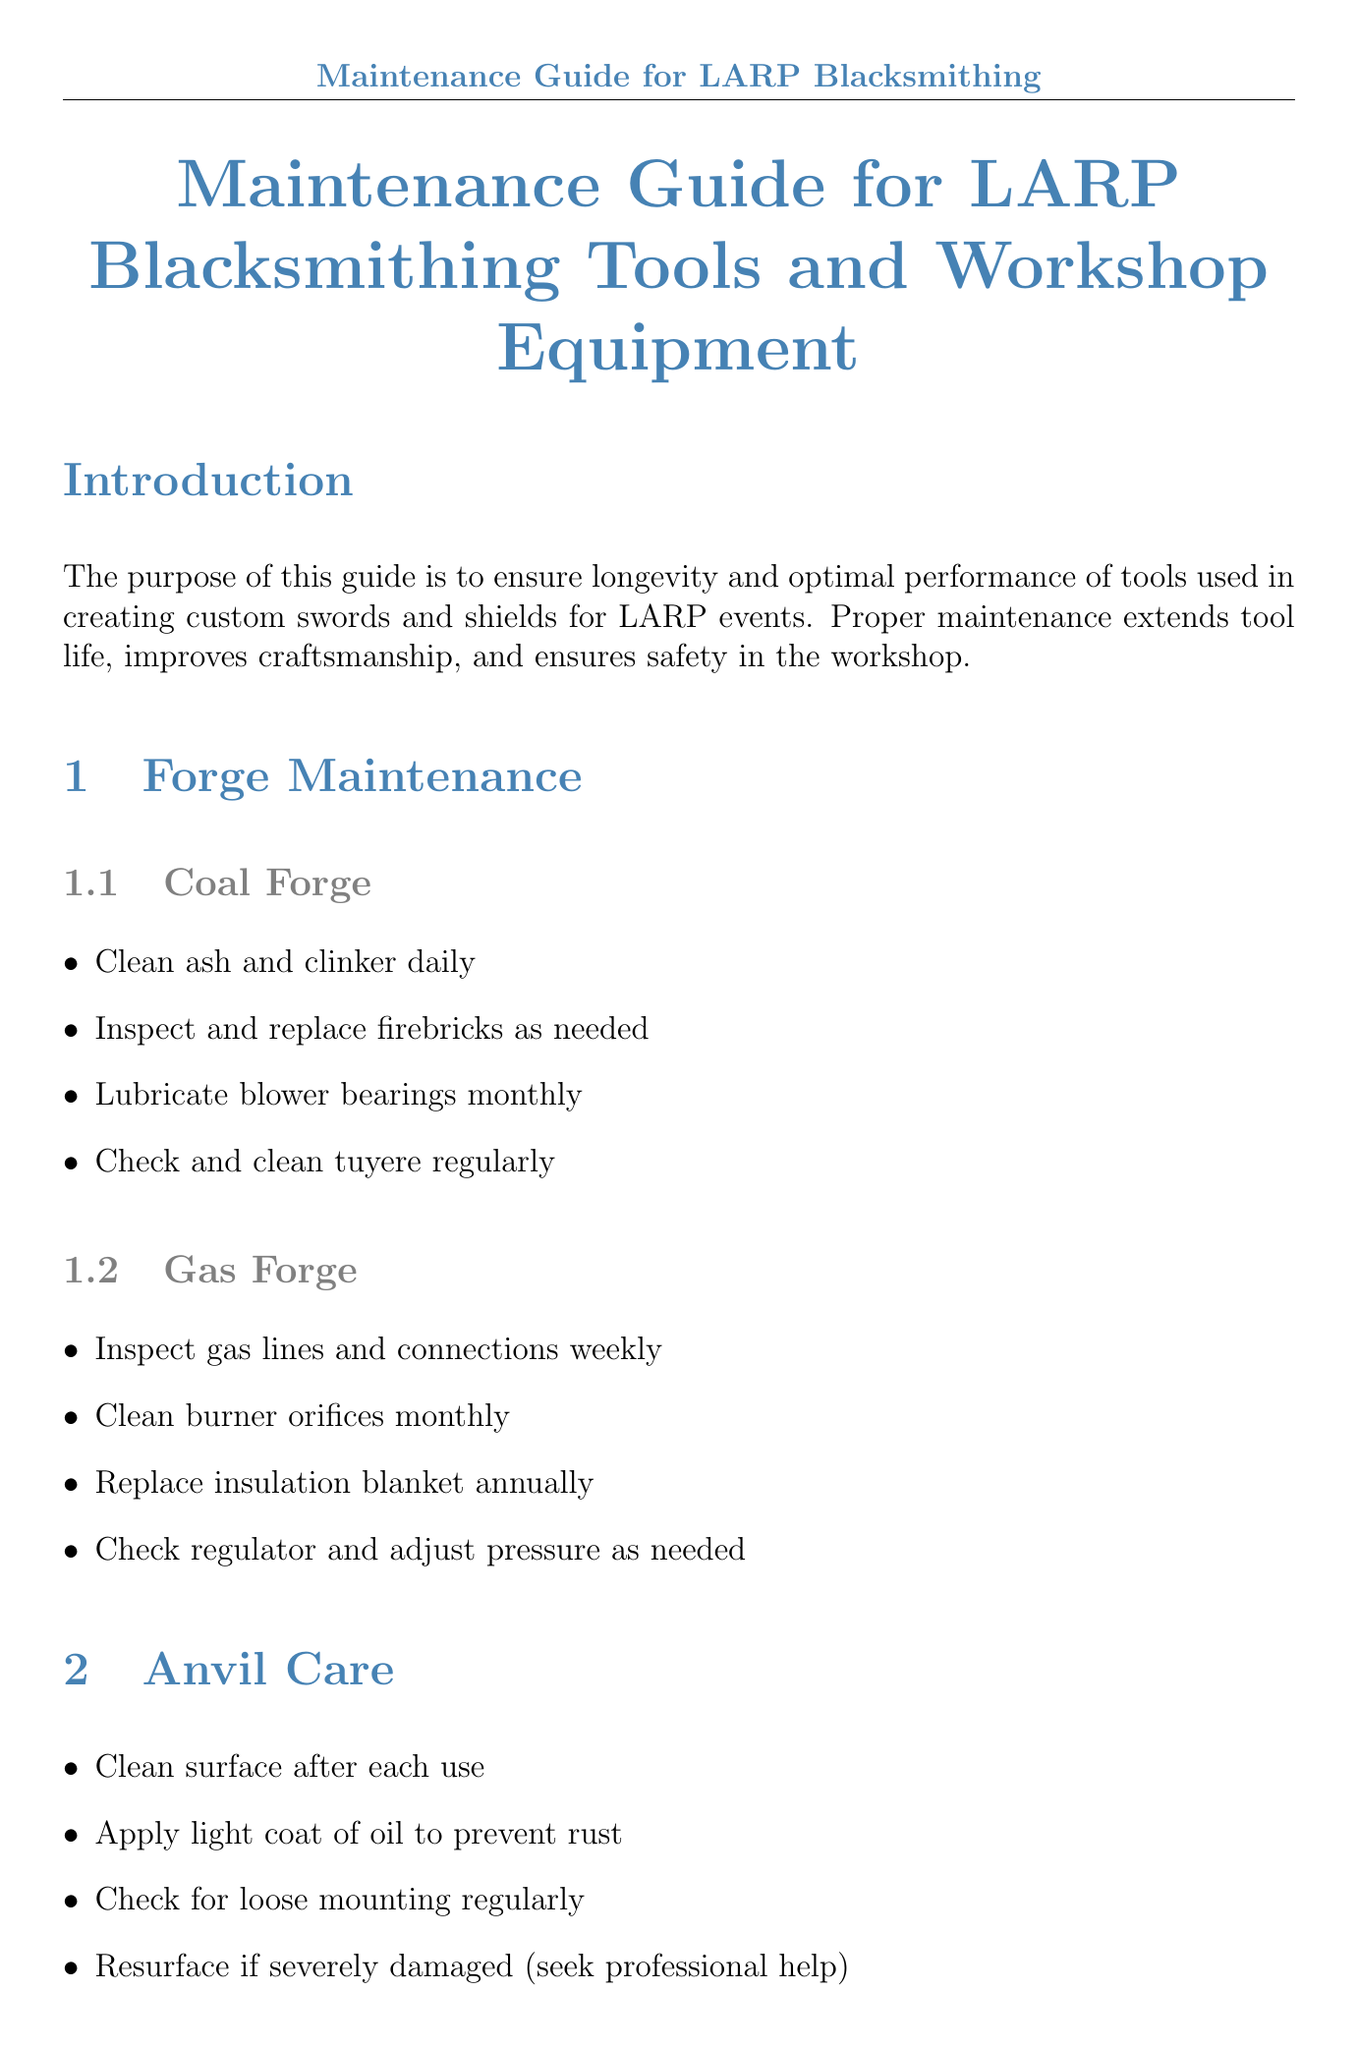what is the purpose of the maintenance guide? The purpose is to ensure longevity and optimal performance of tools used in creating custom swords and shields for LARP events.
Answer: To ensure longevity and optimal performance of tools how often should you clean the air vents of an angle grinder? It should be done after each use to maintain optimal performance.
Answer: after each use what is one task for maintaining a coal forge? One of the tasks is to clean ash and clinker daily for effective operation.
Answer: Clean ash and clinker daily how often should quenching oil be changed? The document states that quenching oil should be changed every 6 months.
Answer: every 6 months what should be done if an anvil is severely damaged? The recommendation is to resurface if severely damaged and seek professional help.
Answer: Seek professional help how frequently should you inspect leather aprons and gloves? The document specifies that they should be inspected monthly for wear.
Answer: monthly what maintenance task is required for the heat treating oven? One task includes calibrating temperature controls annually for accurate performance.
Answer: Calibrate temperature controls annually what should you do to wooden handles of hammers? The guide recommends oiling wooden handles to prevent splitting.
Answer: Oil wooden handles how often should the electrical wiring and outlets be inspected? The document indicates they should be inspected quarterly for safety and functionality.
Answer: quarterly 